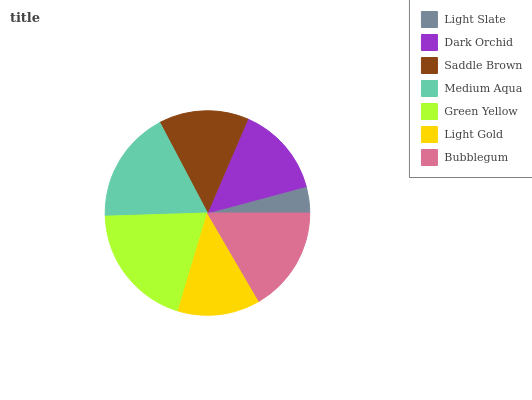Is Light Slate the minimum?
Answer yes or no. Yes. Is Green Yellow the maximum?
Answer yes or no. Yes. Is Dark Orchid the minimum?
Answer yes or no. No. Is Dark Orchid the maximum?
Answer yes or no. No. Is Dark Orchid greater than Light Slate?
Answer yes or no. Yes. Is Light Slate less than Dark Orchid?
Answer yes or no. Yes. Is Light Slate greater than Dark Orchid?
Answer yes or no. No. Is Dark Orchid less than Light Slate?
Answer yes or no. No. Is Dark Orchid the high median?
Answer yes or no. Yes. Is Dark Orchid the low median?
Answer yes or no. Yes. Is Saddle Brown the high median?
Answer yes or no. No. Is Saddle Brown the low median?
Answer yes or no. No. 